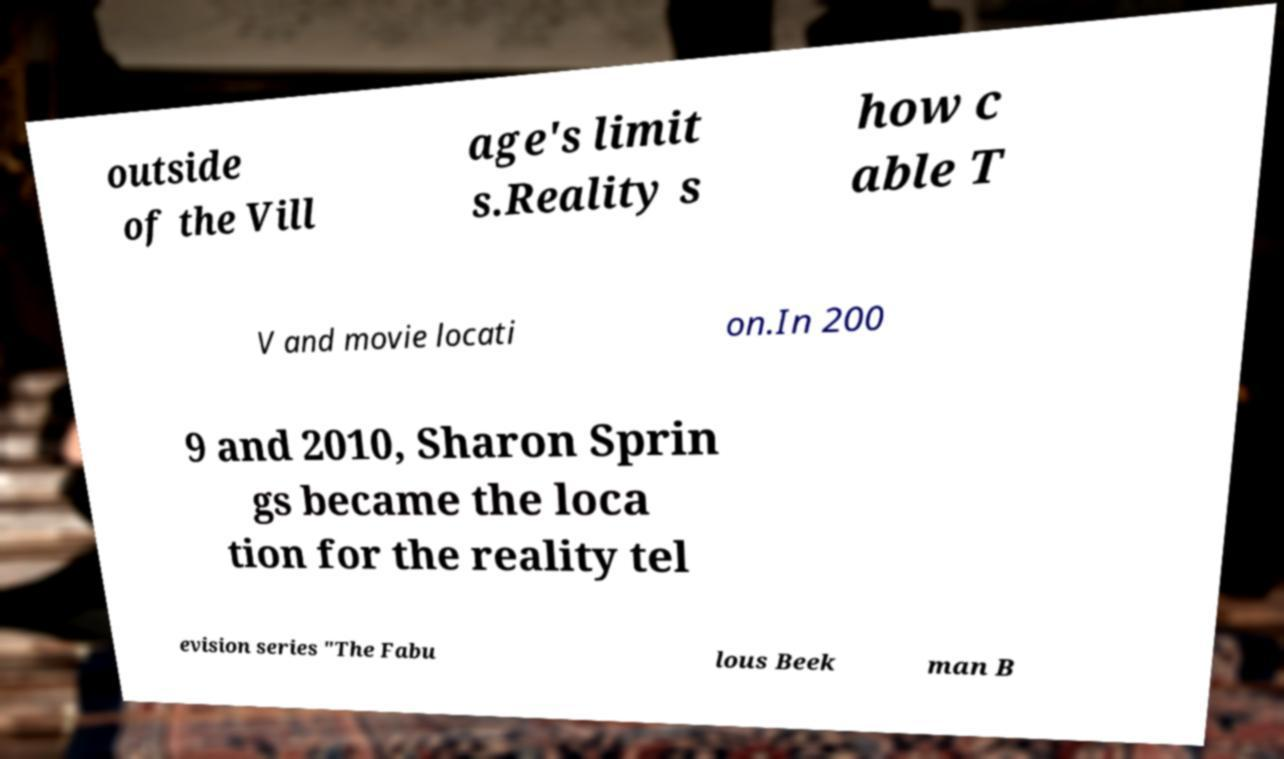Can you accurately transcribe the text from the provided image for me? outside of the Vill age's limit s.Reality s how c able T V and movie locati on.In 200 9 and 2010, Sharon Sprin gs became the loca tion for the reality tel evision series "The Fabu lous Beek man B 